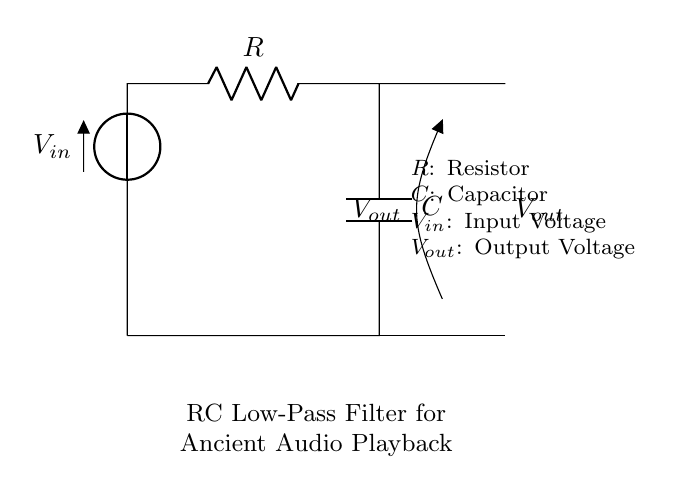What type of filter is represented in the circuit? The circuit is an RC Low-Pass Filter, which allows signals with a frequency lower than a certain cutoff frequency to pass while attenuating higher frequencies. This is indicated by the resistor and capacitor configuration.
Answer: RC Low-Pass Filter What components are present in the circuit? The circuit includes a resistor (R) and a capacitor (C), which are essential elements for creating an RC filter. These components are labeled in the diagram.
Answer: Resistor and Capacitor What is the function of the resistor in this circuit? The resistor limits the current that flows through the circuit and affects the time constant when paired with the capacitor. It is crucial for controlling the cutoff frequency of the filter.
Answer: Current limitation What does \(V_{out}\) represent in the circuit? \(V_{out}\) represents the output voltage which is taken across the capacitor and shows the filtered version of the input signal. This voltage is the result of the RC filtering process.
Answer: Output voltage How does the capacitor affect signals in this circuit? The capacitor charges and discharges based on the input voltage, which smooths out the rapid changes in voltage, thereby filtering out high-frequency noise from the input signal. This behavior is key to the low-pass filtering action of the circuit.
Answer: Smoothing high frequencies What is the role of \(V_{in}\) in this circuit? \(V_{in}\) is the input voltage that is applied to the RC circuit, which then is processed so that signals below a certain frequency pass to \(V_{out}\) while higher frequencies are attenuated. This input signal is essential for the functioning of the filter.
Answer: Input voltage What would happen if the value of the capacitor was increased? Increasing the capacitor's value would result in a lower cutoff frequency, allowing even more low-frequency signals to pass through and attenuating higher frequencies more effectively. This occurs because the time constant of the RC circuit increases with a larger capacitance, leading to slower charge and discharge cycles.
Answer: Lower cutoff frequency 